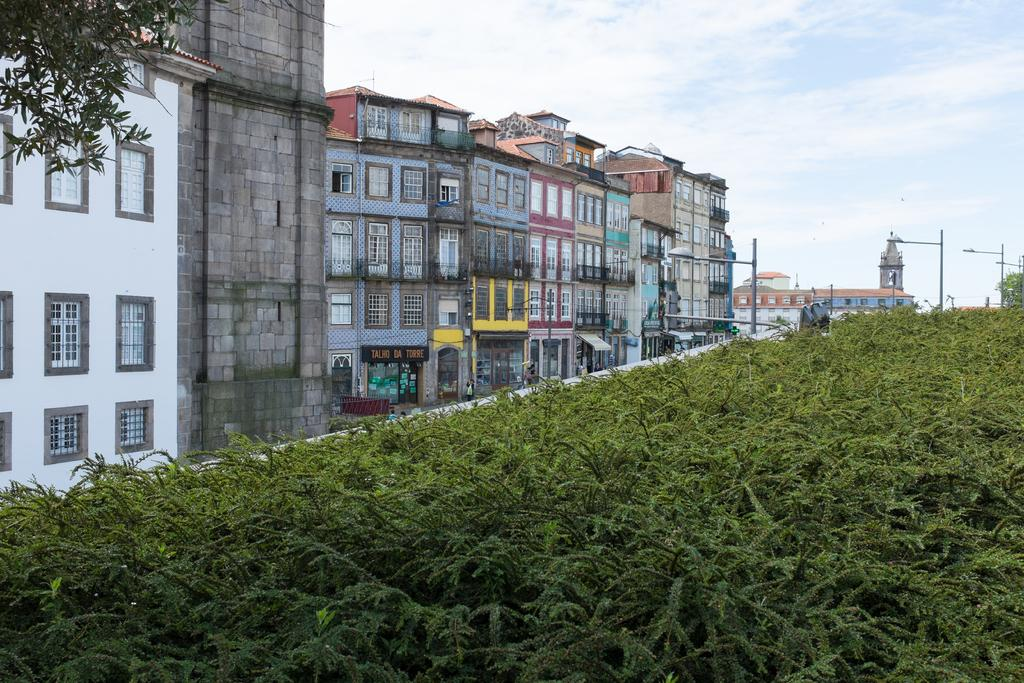What type of vegetation is present in the image? There are green plants in the image. What type of structures can be seen in the image? There are buildings in the image. What feature can be observed on the buildings? There are windows on the buildings. What is visible at the top of the image? The sky is visible at the top of the image. Are there any cobwebs visible on the green plants in the image? There is no mention of cobwebs in the provided facts, and therefore we cannot determine if any are present in the image. Can you see any balls being played with near the buildings in the image? There is no mention of balls or any play activity in the provided facts, and therefore we cannot determine if any are present in the image. 